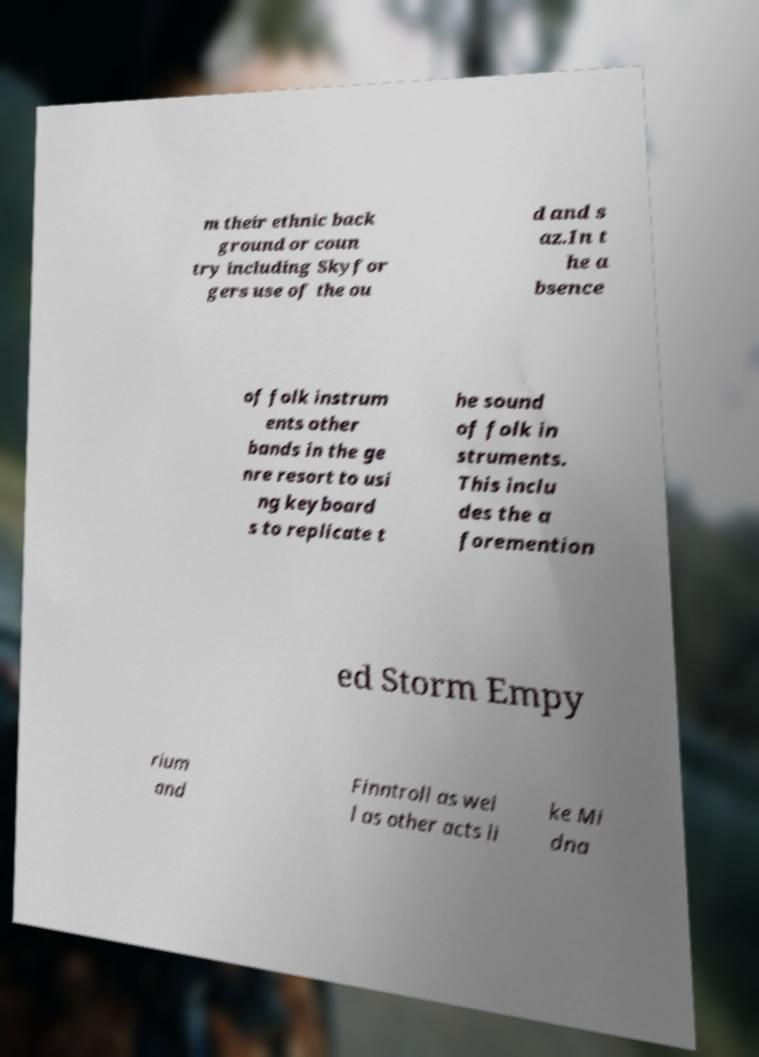Could you assist in decoding the text presented in this image and type it out clearly? m their ethnic back ground or coun try including Skyfor gers use of the ou d and s az.In t he a bsence of folk instrum ents other bands in the ge nre resort to usi ng keyboard s to replicate t he sound of folk in struments. This inclu des the a foremention ed Storm Empy rium and Finntroll as wel l as other acts li ke Mi dna 